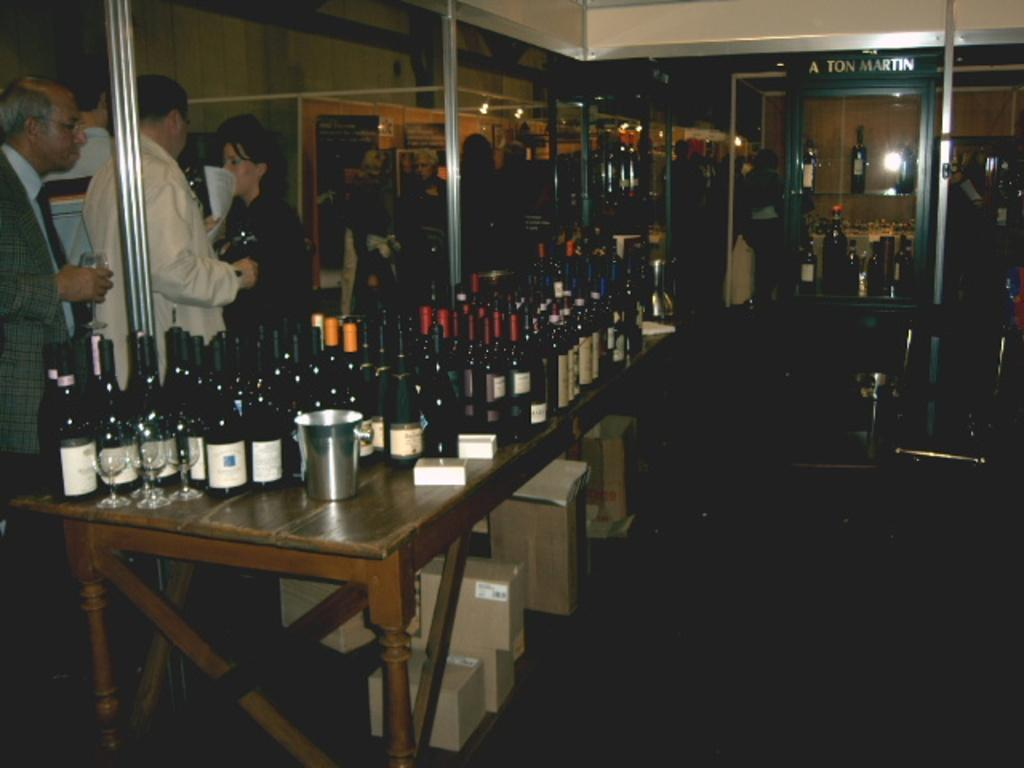What is the man doing on the left side of the image? The man is standing on the left side of the image. What is the man holding in his hands? The man is holding a wine glass in his hands. What can be seen on the table in the middle of the image? There are many wine bottles on a table in the middle of the image. How many children are visible in the image? There are no children visible in the image. What does the caption on the wine bottles say? There is no caption visible on the wine bottles in the image. 